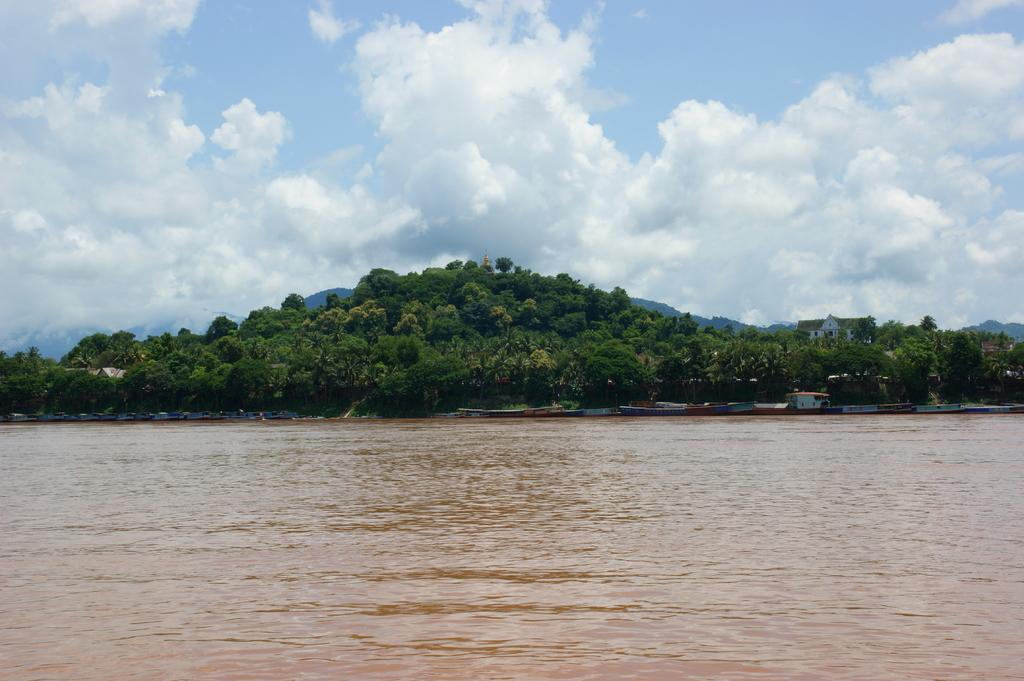What is visible in the image? Water is visible in the image. What can be seen in the background of the image? There are many trees, houses, clouds, and the sky visible in the background of the image. What type of berry can be seen growing on the houses in the image? There are no berries visible on the houses in the image. What kind of animal is interacting with the clouds in the image? There are no animals interacting with the clouds in the image. 